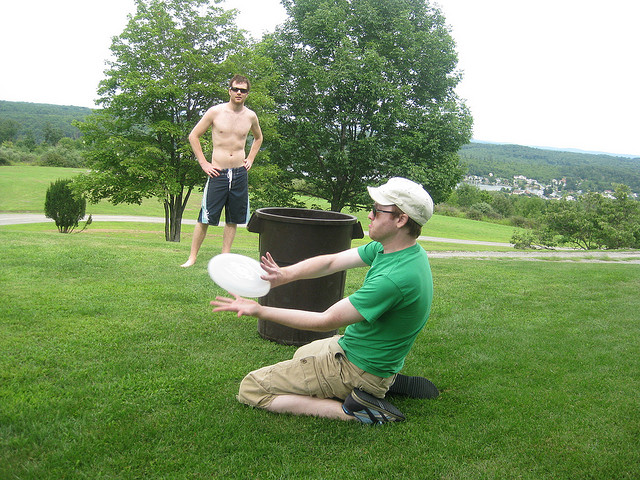What is the man wearing a hat doing?
A. throwing frisbee
B. playing roshambo
C. holding plate
D. catching frisbee
Answer with the option's letter from the given choices directly. D 